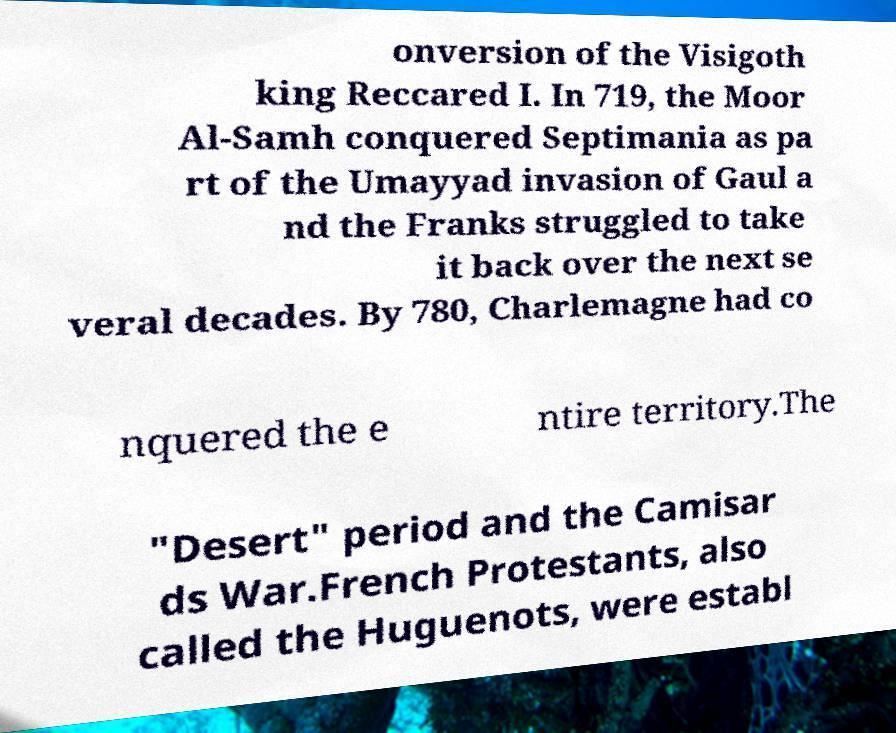I need the written content from this picture converted into text. Can you do that? onversion of the Visigoth king Reccared I. In 719, the Moor Al-Samh conquered Septimania as pa rt of the Umayyad invasion of Gaul a nd the Franks struggled to take it back over the next se veral decades. By 780, Charlemagne had co nquered the e ntire territory.The "Desert" period and the Camisar ds War.French Protestants, also called the Huguenots, were establ 